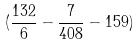<formula> <loc_0><loc_0><loc_500><loc_500>( \frac { 1 3 2 } { 6 } - \frac { 7 } { 4 0 8 } - 1 5 9 )</formula> 